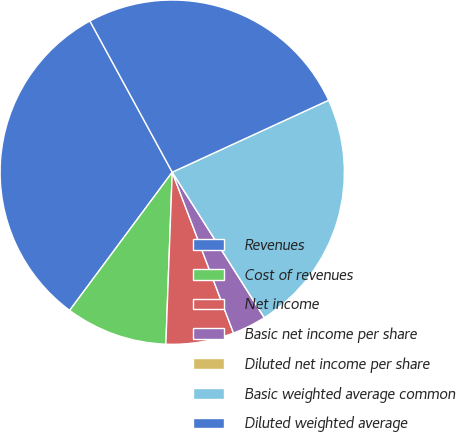Convert chart. <chart><loc_0><loc_0><loc_500><loc_500><pie_chart><fcel>Revenues<fcel>Cost of revenues<fcel>Net income<fcel>Basic net income per share<fcel>Diluted net income per share<fcel>Basic weighted average common<fcel>Diluted weighted average<nl><fcel>31.9%<fcel>9.57%<fcel>6.38%<fcel>3.19%<fcel>0.0%<fcel>22.88%<fcel>26.07%<nl></chart> 